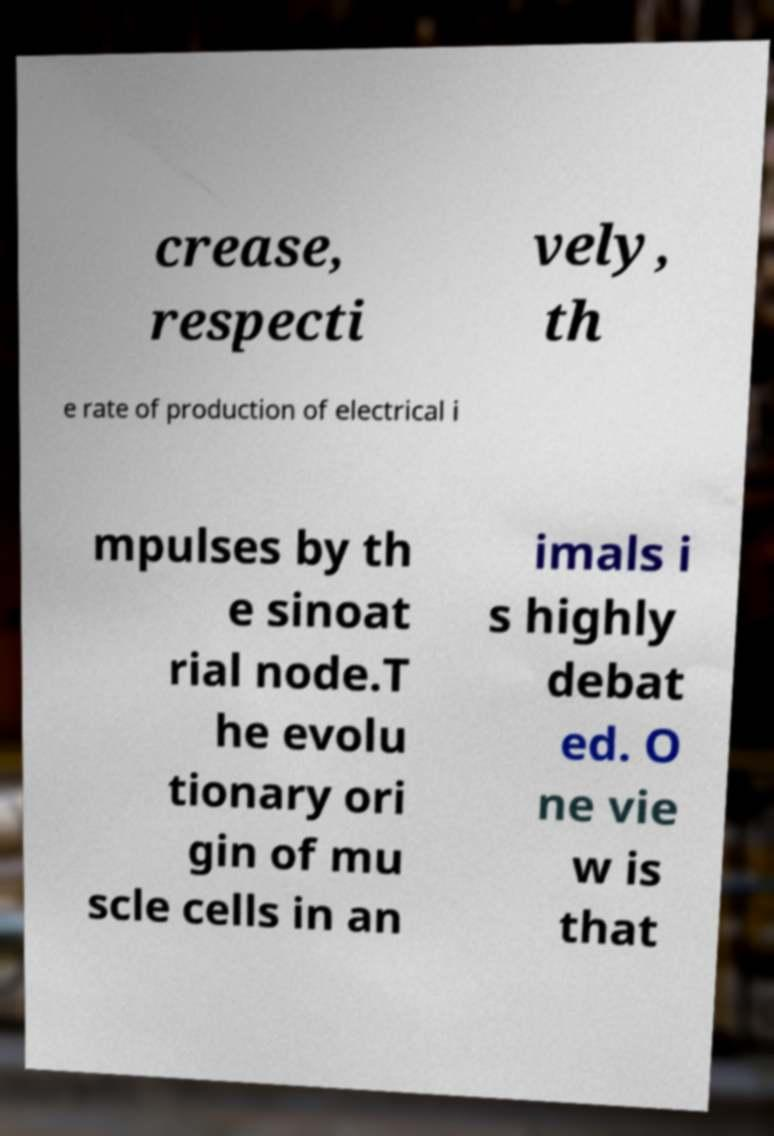There's text embedded in this image that I need extracted. Can you transcribe it verbatim? crease, respecti vely, th e rate of production of electrical i mpulses by th e sinoat rial node.T he evolu tionary ori gin of mu scle cells in an imals i s highly debat ed. O ne vie w is that 